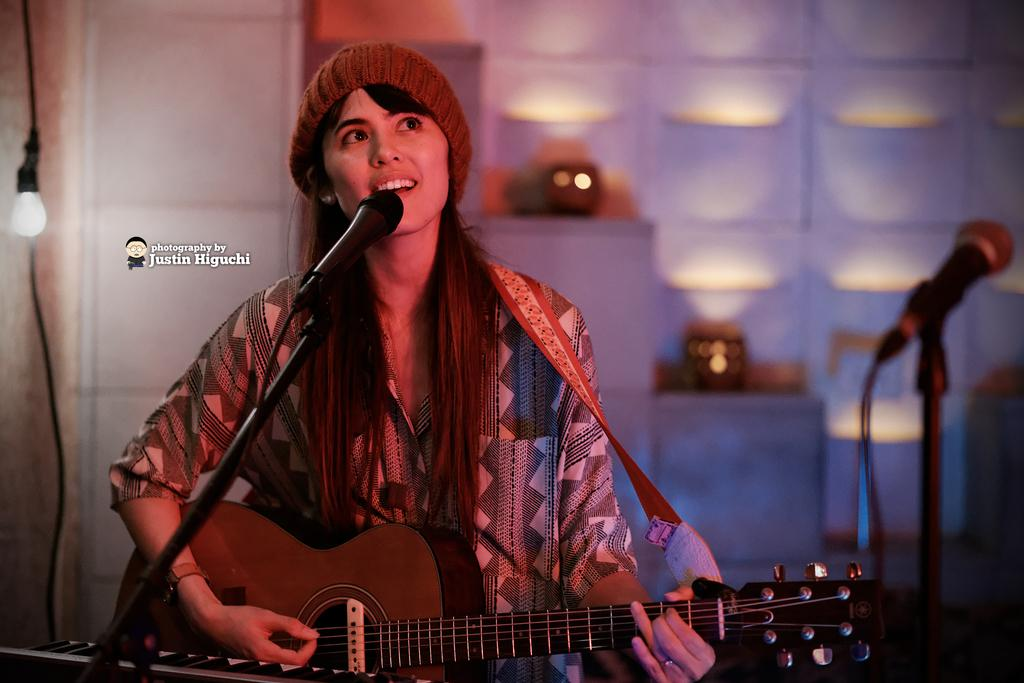Who is the main subject in the image? There is a girl in the image. What is the girl holding in the image? The girl is holding a guitar and a microphone. What is the girl doing with the guitar? The girl is playing the guitar. How many microphones are visible in the image? There are two microphones visible in the image. What is the girl wearing in the image? The girl is wearing a black and white shirt. What type of question is being asked on the canvas in the image? There is no canvas present in the image, and therefore no questions can be asked on it. 